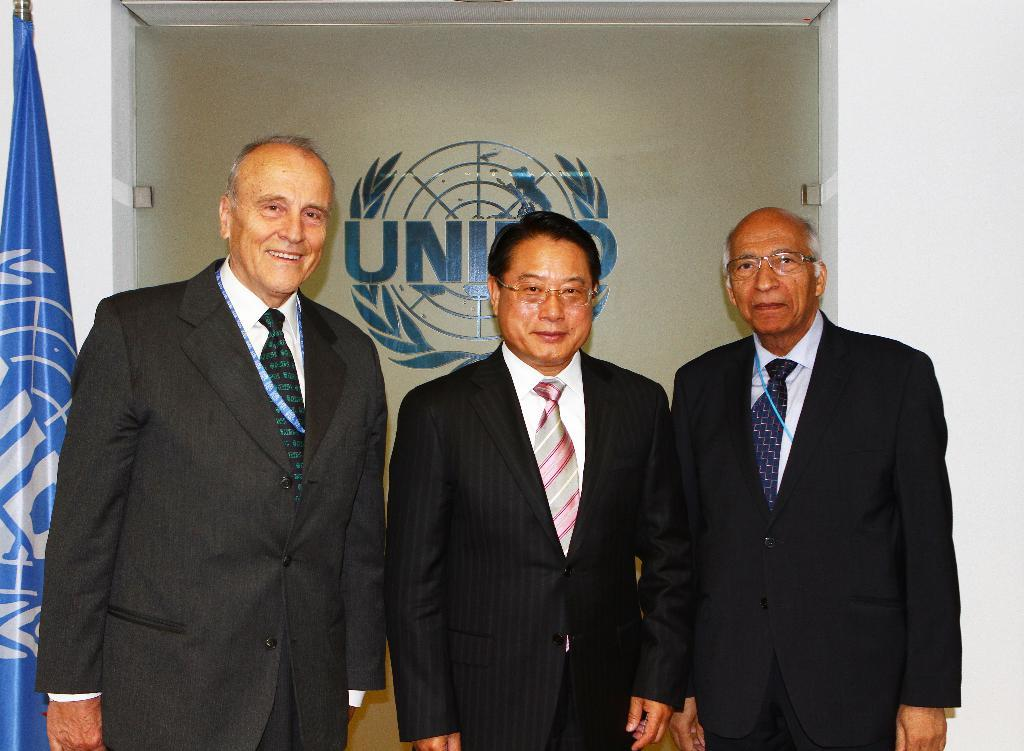What is the main subject in the center of the image? There are persons in the center of the image. What can be seen in the background of the image? There is a flag and a wall in the background of the image. What type of glue is being used by the persons in the image? There is no glue present in the image, and therefore no such activity can be observed. 